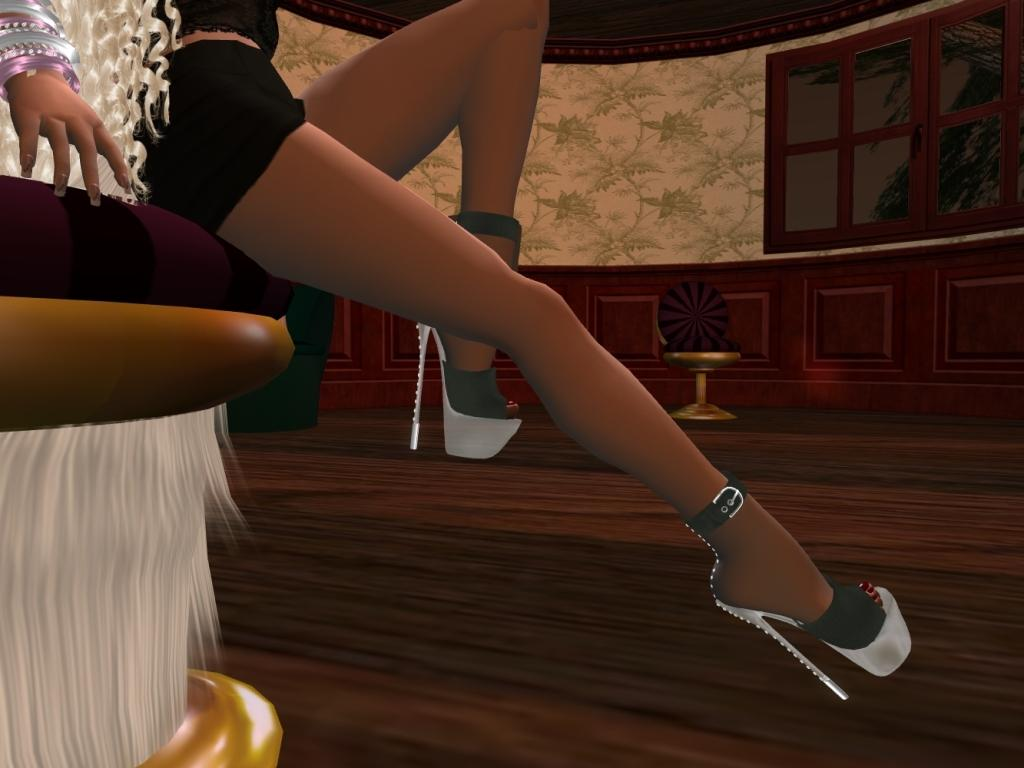What type of image is being described? The image is an animation and graphic. What part of a person can be seen in the center of the image? The legs of a woman are visible in the center of the image. What architectural features are present in the background of the image? There are windows and a wall in the background of the image. How does the woman measure the distance between the windows in the image? The image is an animation and graphic, and there is no indication of measuring tools or actions in the image. 